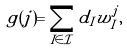Convert formula to latex. <formula><loc_0><loc_0><loc_500><loc_500>g ( j ) = \sum _ { I \in \mathcal { I } } d _ { I } w _ { I } ^ { j } ,</formula> 